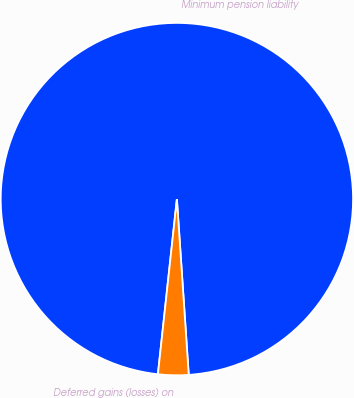<chart> <loc_0><loc_0><loc_500><loc_500><pie_chart><fcel>Minimum pension liability<fcel>Deferred gains (losses) on<nl><fcel>97.21%<fcel>2.79%<nl></chart> 